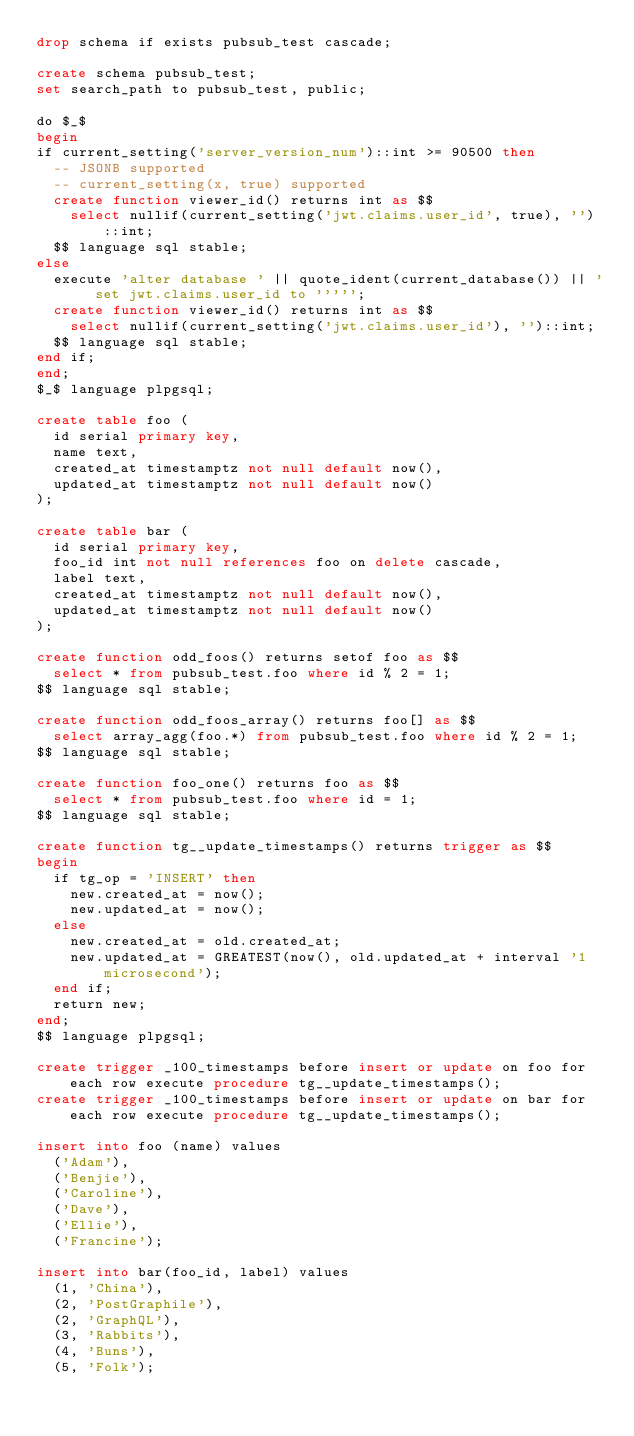Convert code to text. <code><loc_0><loc_0><loc_500><loc_500><_SQL_>drop schema if exists pubsub_test cascade;

create schema pubsub_test;
set search_path to pubsub_test, public;

do $_$
begin
if current_setting('server_version_num')::int >= 90500 then
  -- JSONB supported
  -- current_setting(x, true) supported
  create function viewer_id() returns int as $$
    select nullif(current_setting('jwt.claims.user_id', true), '')::int;
  $$ language sql stable;
else
  execute 'alter database ' || quote_ident(current_database()) || ' set jwt.claims.user_id to ''''';
  create function viewer_id() returns int as $$
    select nullif(current_setting('jwt.claims.user_id'), '')::int;
  $$ language sql stable;
end if;
end;
$_$ language plpgsql;

create table foo (
  id serial primary key,
  name text,
  created_at timestamptz not null default now(),
  updated_at timestamptz not null default now()
);

create table bar (
  id serial primary key,
  foo_id int not null references foo on delete cascade,
  label text,
  created_at timestamptz not null default now(),
  updated_at timestamptz not null default now()
);

create function odd_foos() returns setof foo as $$
  select * from pubsub_test.foo where id % 2 = 1;
$$ language sql stable;

create function odd_foos_array() returns foo[] as $$
  select array_agg(foo.*) from pubsub_test.foo where id % 2 = 1;
$$ language sql stable;

create function foo_one() returns foo as $$
  select * from pubsub_test.foo where id = 1;
$$ language sql stable;

create function tg__update_timestamps() returns trigger as $$
begin
  if tg_op = 'INSERT' then
    new.created_at = now();
    new.updated_at = now();
  else
    new.created_at = old.created_at;
    new.updated_at = GREATEST(now(), old.updated_at + interval '1 microsecond');
  end if;
  return new;
end;
$$ language plpgsql;

create trigger _100_timestamps before insert or update on foo for each row execute procedure tg__update_timestamps();
create trigger _100_timestamps before insert or update on bar for each row execute procedure tg__update_timestamps();

insert into foo (name) values
  ('Adam'),
  ('Benjie'),
  ('Caroline'),
  ('Dave'),
  ('Ellie'),
  ('Francine');

insert into bar(foo_id, label) values
  (1, 'China'),
  (2, 'PostGraphile'),
  (2, 'GraphQL'),
  (3, 'Rabbits'),
  (4, 'Buns'),
  (5, 'Folk');
</code> 